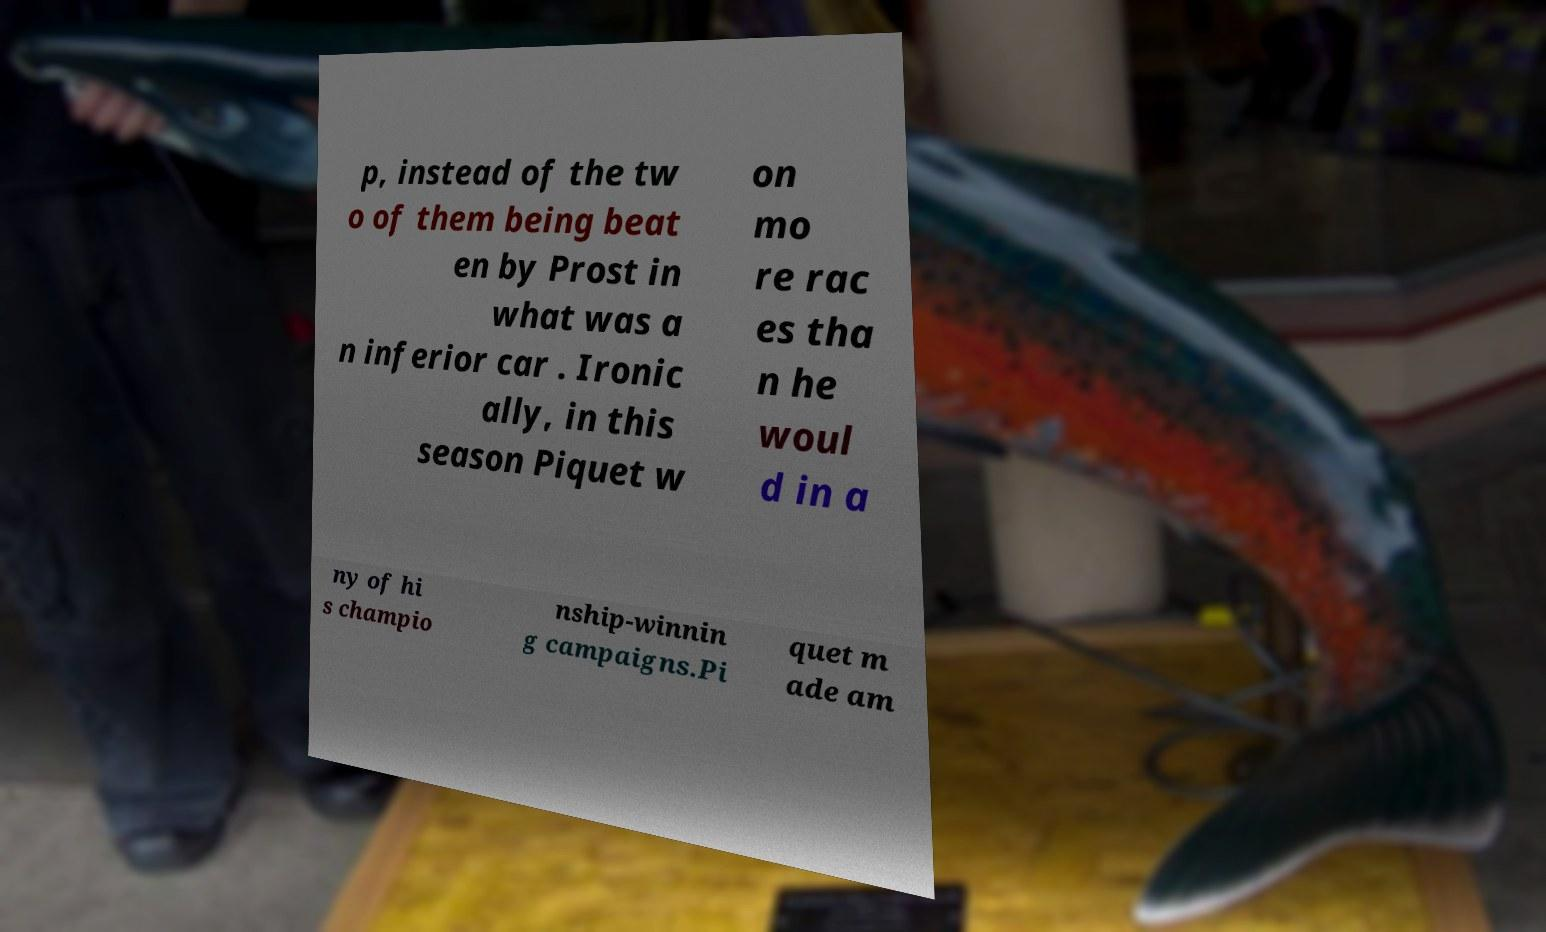Please read and relay the text visible in this image. What does it say? p, instead of the tw o of them being beat en by Prost in what was a n inferior car . Ironic ally, in this season Piquet w on mo re rac es tha n he woul d in a ny of hi s champio nship-winnin g campaigns.Pi quet m ade am 